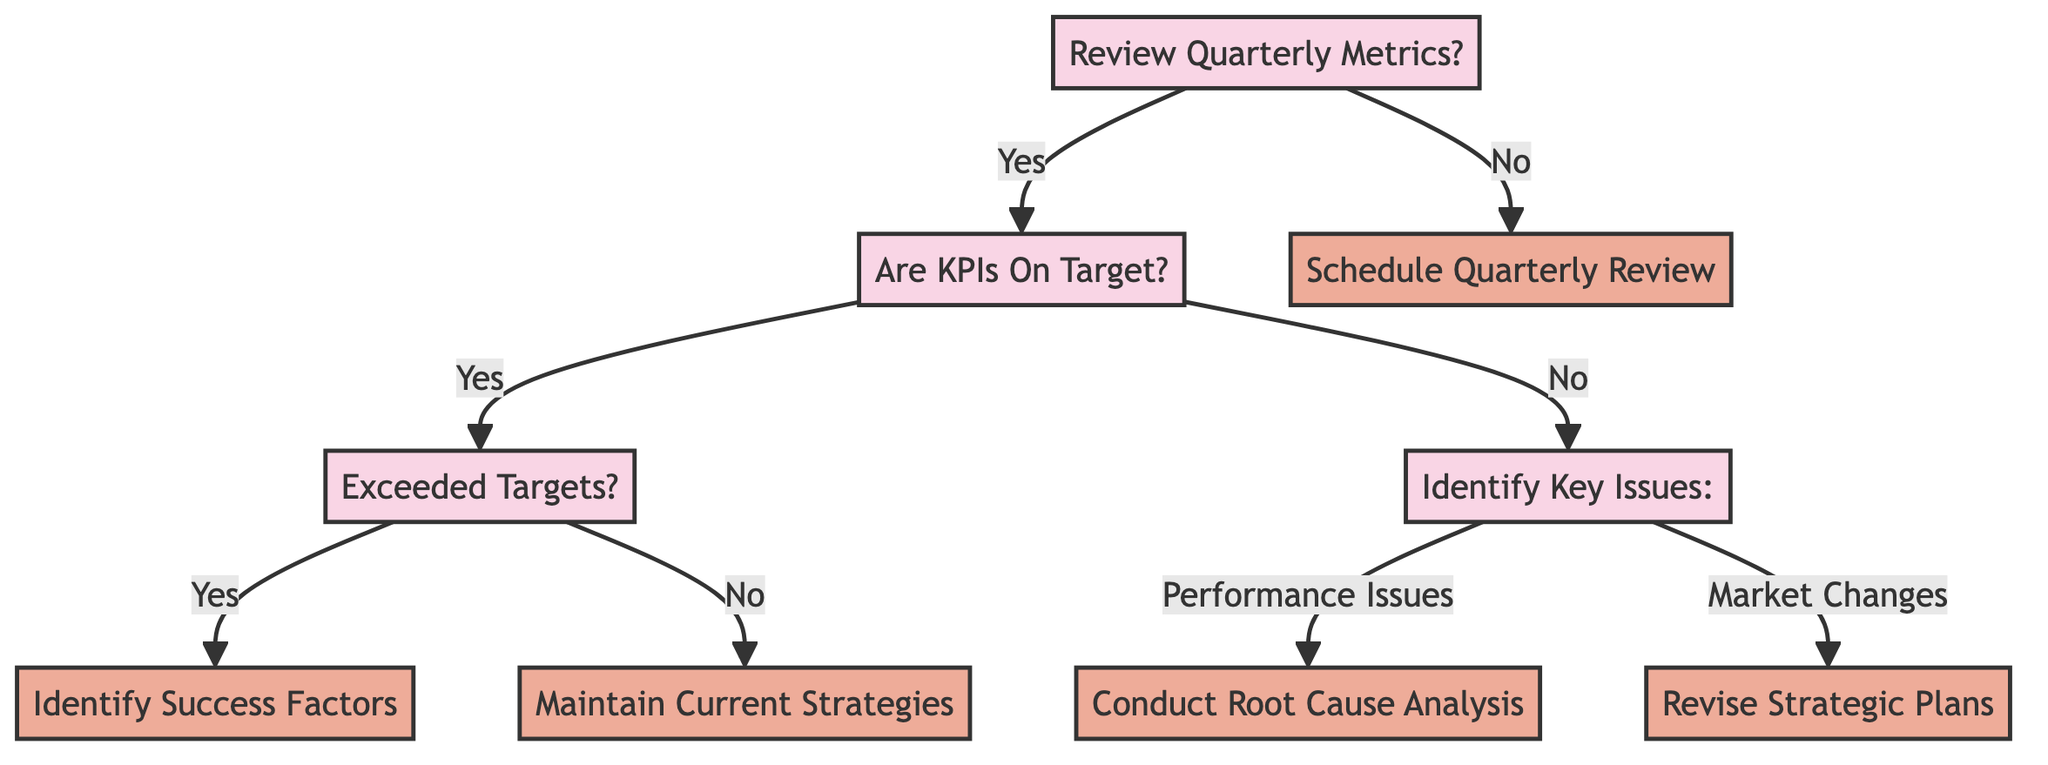What is the first decision in the diagram? The first decision in the diagram is "Review Quarterly Metrics?". This can be identified as the starting point of the decision tree.
Answer: Review Quarterly Metrics? How many actions are identified in the diagram? The diagram shows four actions: "Identify Success Factors", "Maintain Current Strategies", "Conduct Root Cause Analysis", and "Revise Strategic Plans". Counting these gives a total of four actions.
Answer: 4 What action follows if KPIs are on target but targets are not exceeded? If KPIs are on target but targets are not exceeded, the next step is "Maintain Current Strategies". This is derived from the path that starts with "Are KPIs On Target?" leading to "Exceeded Targets?" and then to the respective action.
Answer: Maintain Current Strategies Which decision leads to conducting a root cause analysis? The decision that leads to conducting a root cause analysis is "Identify Key Issues:", specifically the path chosen if there are "Performance Issues". This requires acknowledging that KPIs are not on target first.
Answer: Identify Key Issues: What happens if the answer to "Review Quarterly Metrics?" is No? If the answer to "Review Quarterly Metrics?" is No, the next action taken is "Schedule Quarterly Review". This is a direct outcome of that decision node.
Answer: Schedule Quarterly Review If market changes are identified, what action should be taken? If market changes are identified under the "Identify Key Issues:", the action to be taken is "Revise Strategic Plans". This follows from the reasoning that if the KPIs are not on target and market changes are a root cause, the strategic plans need adjustments.
Answer: Revise Strategic Plans How many decision nodes are there in the diagram? The diagram consists of five decision nodes: "Review Quarterly Metrics?", "Are KPIs On Target?", "Exceeded Targets?", and "Identify Key Issues:". Counting each of these nodes gives a total of four decisions along with the root.
Answer: 5 What is the outcome if metrics are reviewed and KPIs are found not to be on target due to performance issues? The outcome of reviewing metrics, finding KPIs not on target, and identifying performance issues would lead to "Conduct Root Cause Analysis". This follows the path specified for identifying problems and actions to take.
Answer: Conduct Root Cause Analysis What is the last action in the decision tree? The last action in the decision tree is "Revise Strategic Plans". This action appears under the decision of identifying market changes when KPIs are off target, showing a potential response to relevant issues identified during the review.
Answer: Revise Strategic Plans 